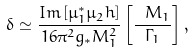<formula> <loc_0><loc_0><loc_500><loc_500>\delta \simeq { \frac { { I m \left [ \mu _ { 1 } ^ { * } \mu _ { 2 } h \right ] } } { { 1 6 \pi ^ { 2 } g _ { * } M _ { 1 } ^ { 2 } } } } \left [ { \frac { { \ M _ { 1 } } } { \Gamma _ { 1 } } } \right ] ,</formula> 